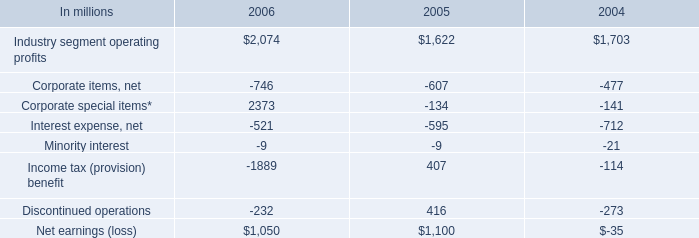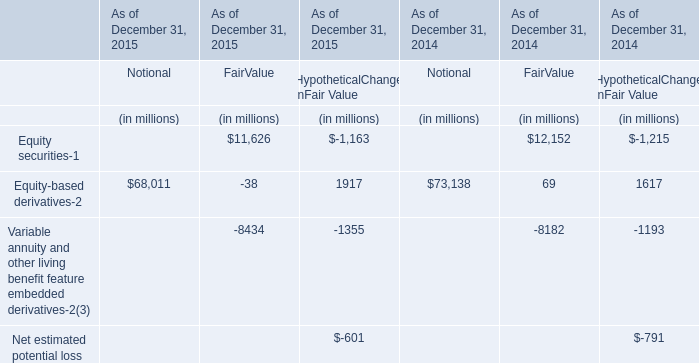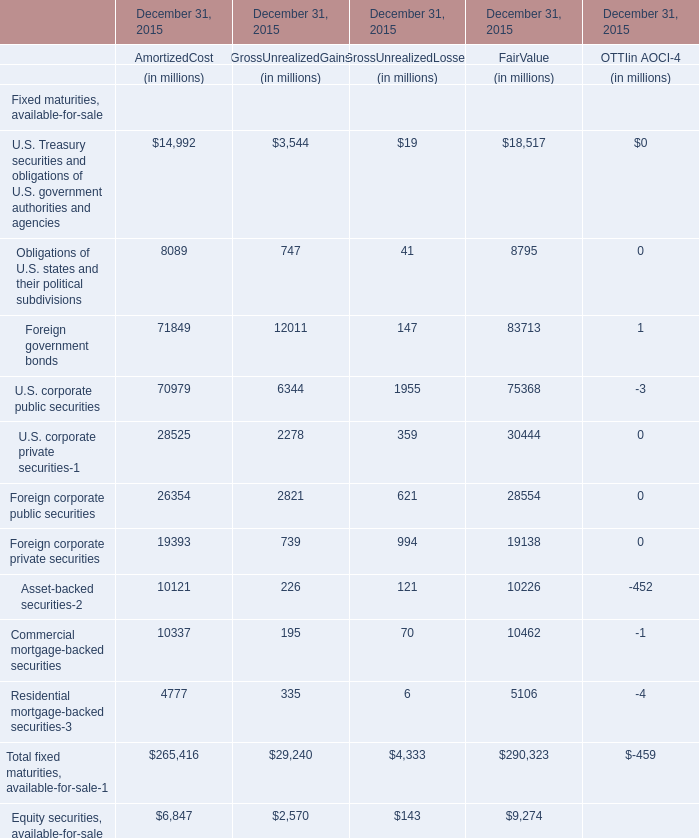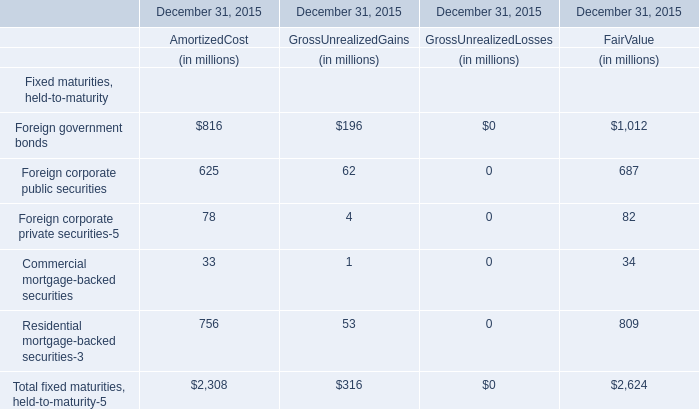what was the average industry segment operating profits from 2004 to 2006 
Computations: (1703 + (2074 + 1622))
Answer: 5399.0. 